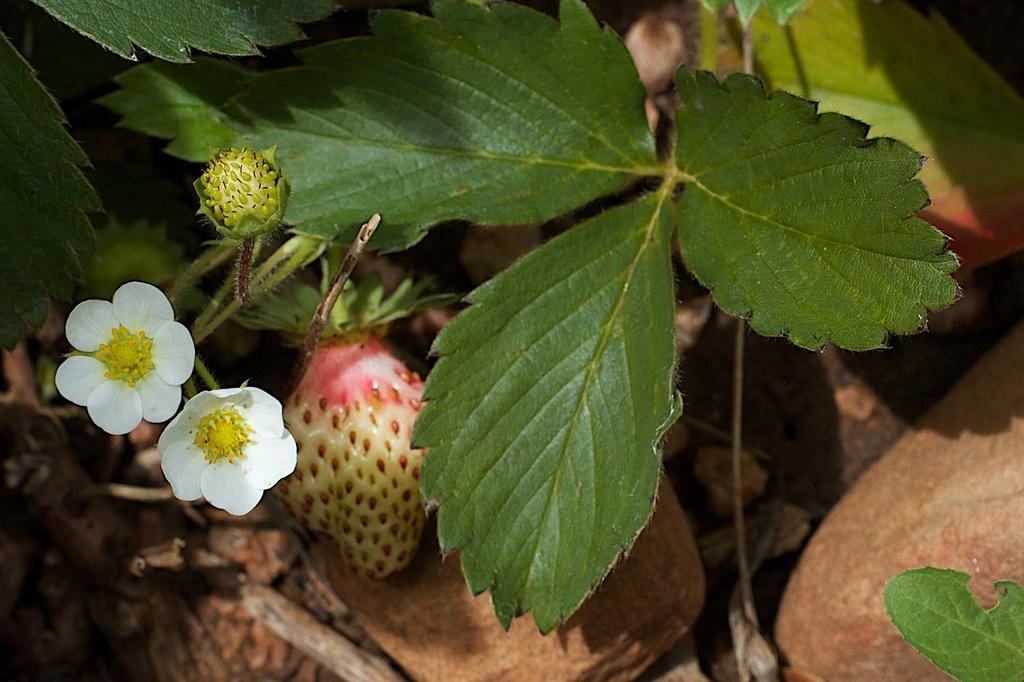Could you give a brief overview of what you see in this image? In the foreground of this image, there is a plant to which there are two flowers, a bud and a strawberry. On the bottom, there are few dried leaves. 